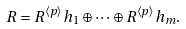Convert formula to latex. <formula><loc_0><loc_0><loc_500><loc_500>R = R ^ { \langle p \rangle } h _ { 1 } \oplus \cdots \oplus R ^ { \langle p \rangle } h _ { m } .</formula> 